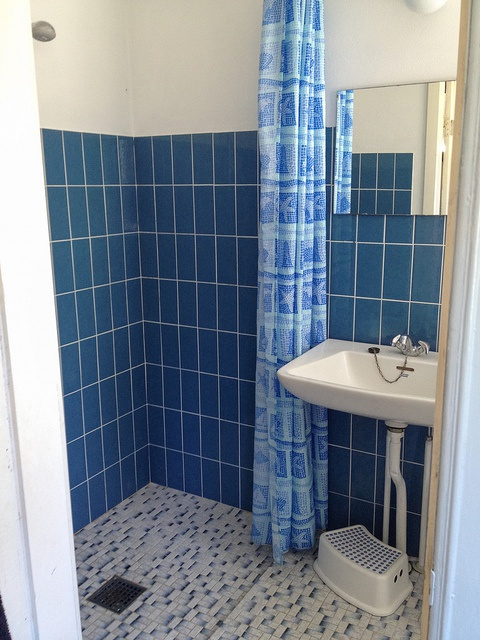Describe the objects in this image and their specific colors. I can see a sink in beige, darkgray, and lightgray tones in this image. 